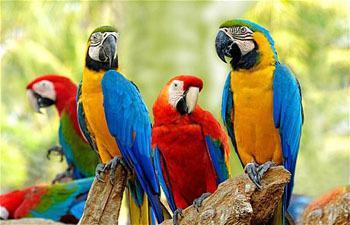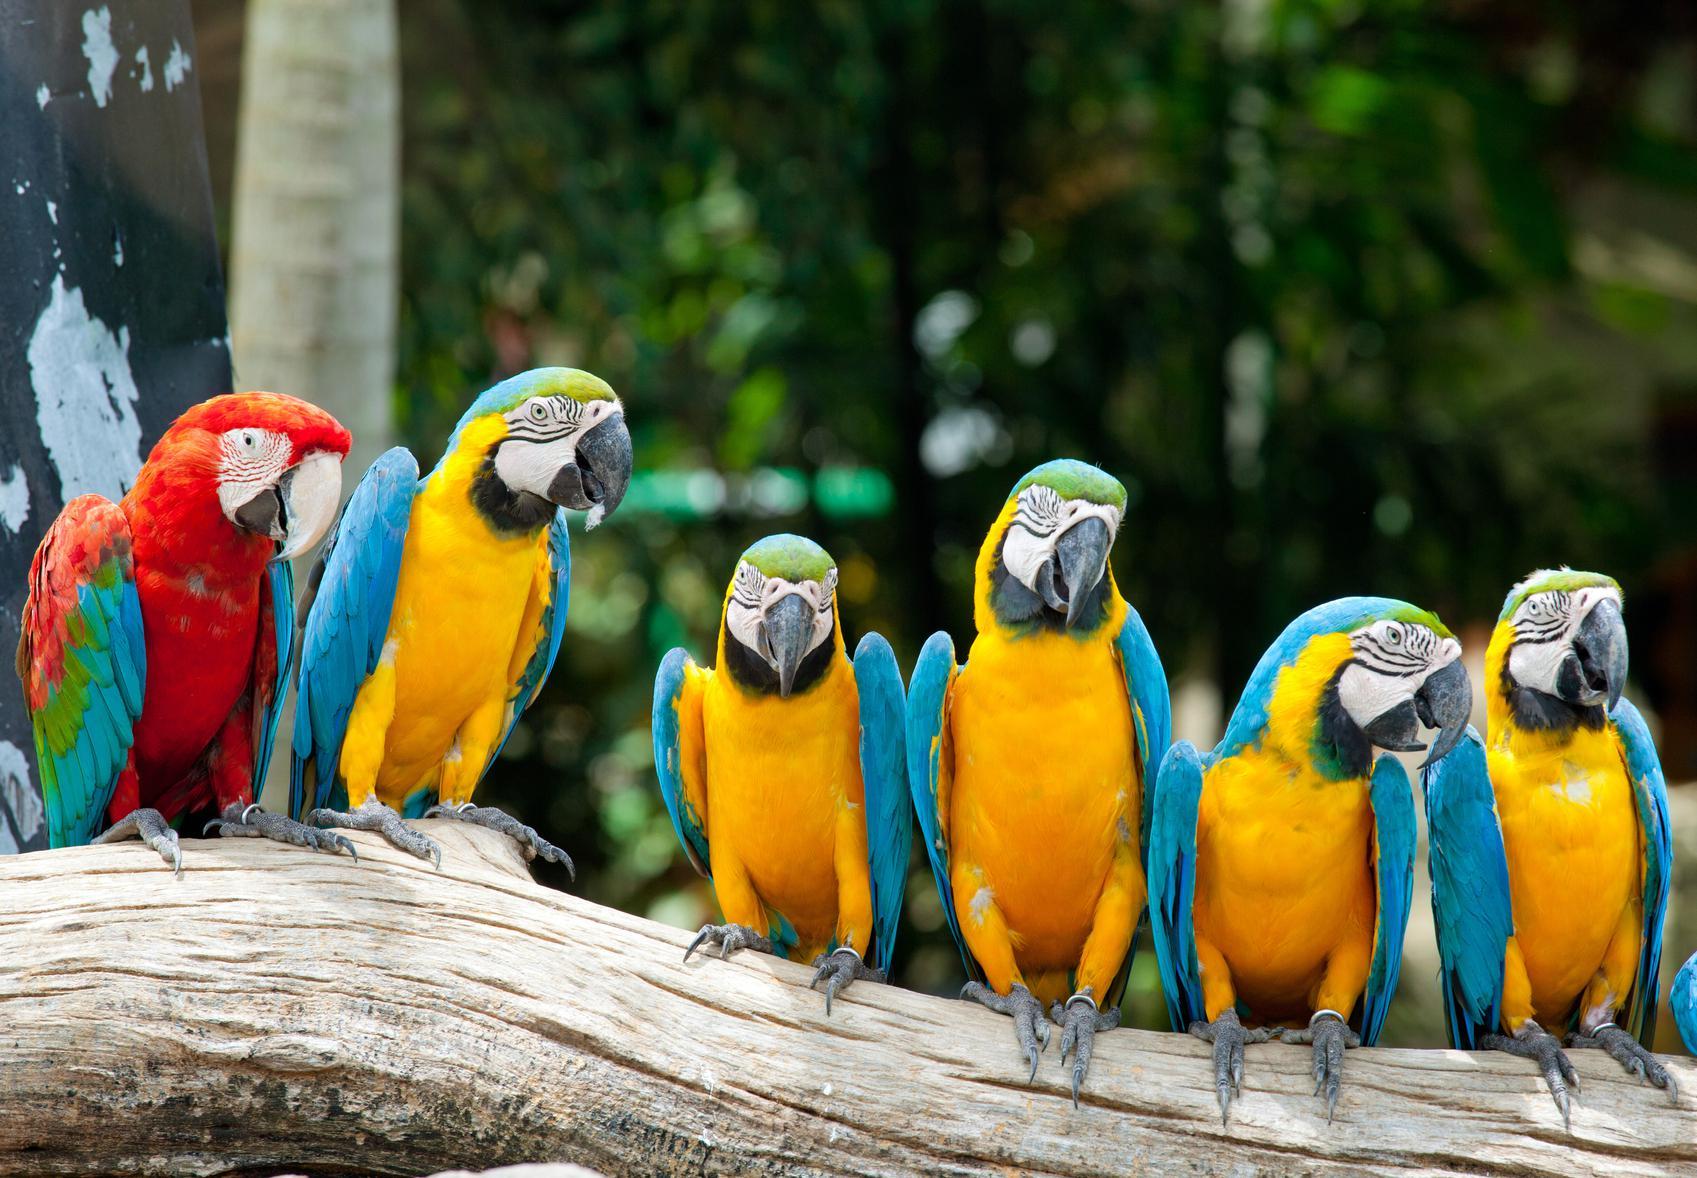The first image is the image on the left, the second image is the image on the right. Examine the images to the left and right. Is the description "The image to the right is a row of yellow fronted macaws with one red one at the left end." accurate? Answer yes or no. Yes. 